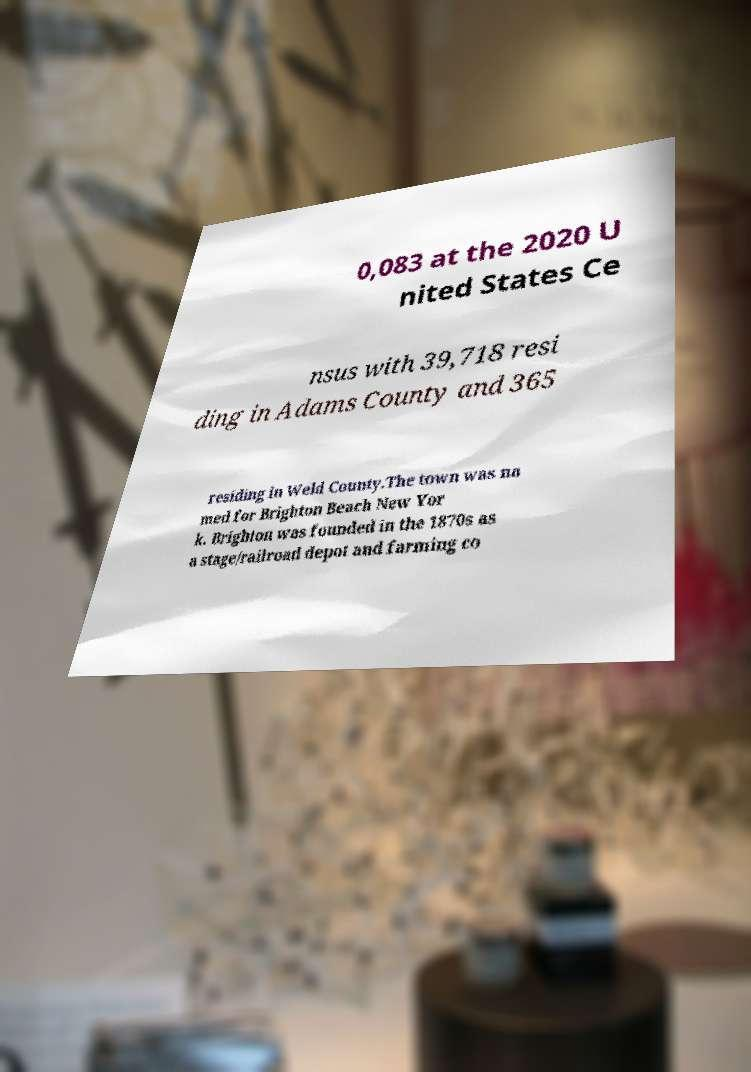I need the written content from this picture converted into text. Can you do that? 0,083 at the 2020 U nited States Ce nsus with 39,718 resi ding in Adams County and 365 residing in Weld County.The town was na med for Brighton Beach New Yor k. Brighton was founded in the 1870s as a stage/railroad depot and farming co 